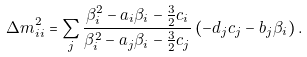Convert formula to latex. <formula><loc_0><loc_0><loc_500><loc_500>\Delta m _ { i i } ^ { 2 } = \sum _ { j } \frac { \beta ^ { 2 } _ { i } - a _ { i } \beta _ { i } - \frac { 3 } { 2 } c _ { i } } { \beta ^ { 2 } _ { i } - a _ { j } \beta _ { i } - \frac { 3 } { 2 } c _ { j } } \left ( - d _ { j } c _ { j } - b _ { j } \beta _ { i } \right ) .</formula> 